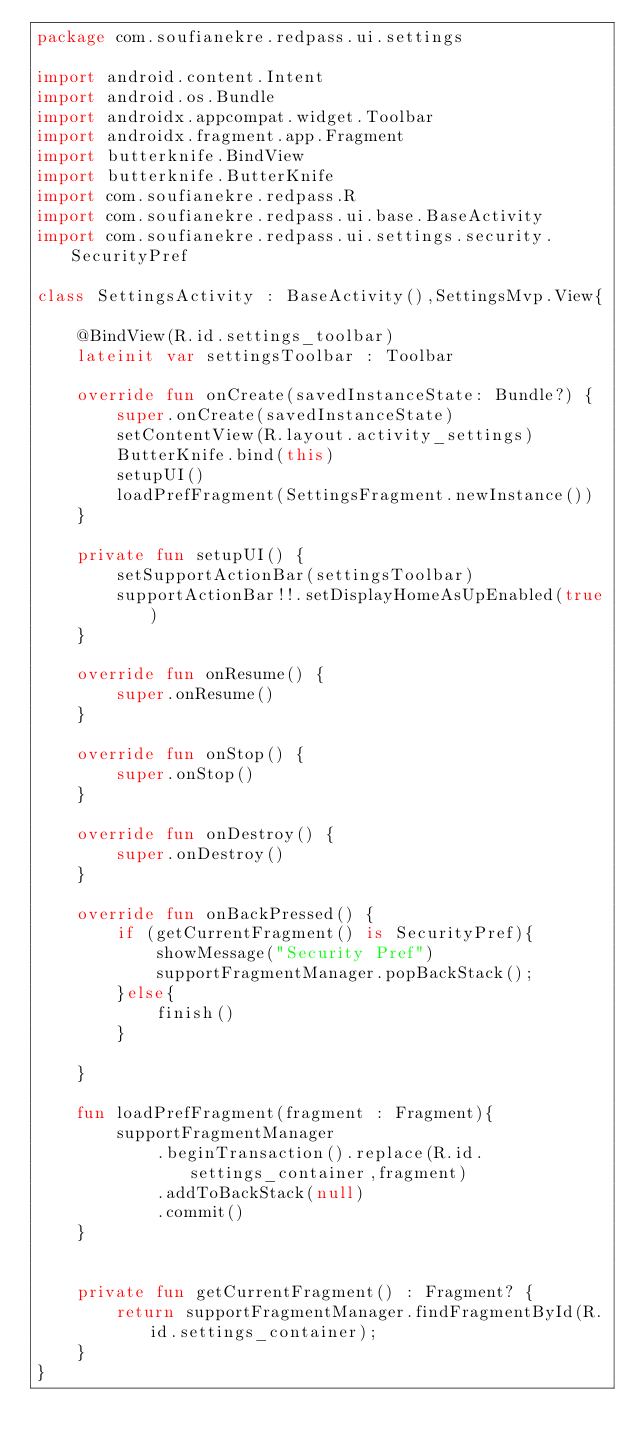<code> <loc_0><loc_0><loc_500><loc_500><_Kotlin_>package com.soufianekre.redpass.ui.settings

import android.content.Intent
import android.os.Bundle
import androidx.appcompat.widget.Toolbar
import androidx.fragment.app.Fragment
import butterknife.BindView
import butterknife.ButterKnife
import com.soufianekre.redpass.R
import com.soufianekre.redpass.ui.base.BaseActivity
import com.soufianekre.redpass.ui.settings.security.SecurityPref

class SettingsActivity : BaseActivity(),SettingsMvp.View{

    @BindView(R.id.settings_toolbar)
    lateinit var settingsToolbar : Toolbar

    override fun onCreate(savedInstanceState: Bundle?) {
        super.onCreate(savedInstanceState)
        setContentView(R.layout.activity_settings)
        ButterKnife.bind(this)
        setupUI()
        loadPrefFragment(SettingsFragment.newInstance())
    }

    private fun setupUI() {
        setSupportActionBar(settingsToolbar)
        supportActionBar!!.setDisplayHomeAsUpEnabled(true)
    }

    override fun onResume() {
        super.onResume()
    }

    override fun onStop() {
        super.onStop()
    }

    override fun onDestroy() {
        super.onDestroy()
    }

    override fun onBackPressed() {
        if (getCurrentFragment() is SecurityPref){
            showMessage("Security Pref")
            supportFragmentManager.popBackStack();
        }else{
            finish()
        }

    }

    fun loadPrefFragment(fragment : Fragment){
        supportFragmentManager
            .beginTransaction().replace(R.id.settings_container,fragment)
            .addToBackStack(null)
            .commit()
    }


    private fun getCurrentFragment() : Fragment? {
        return supportFragmentManager.findFragmentById(R.id.settings_container);
    }
}</code> 